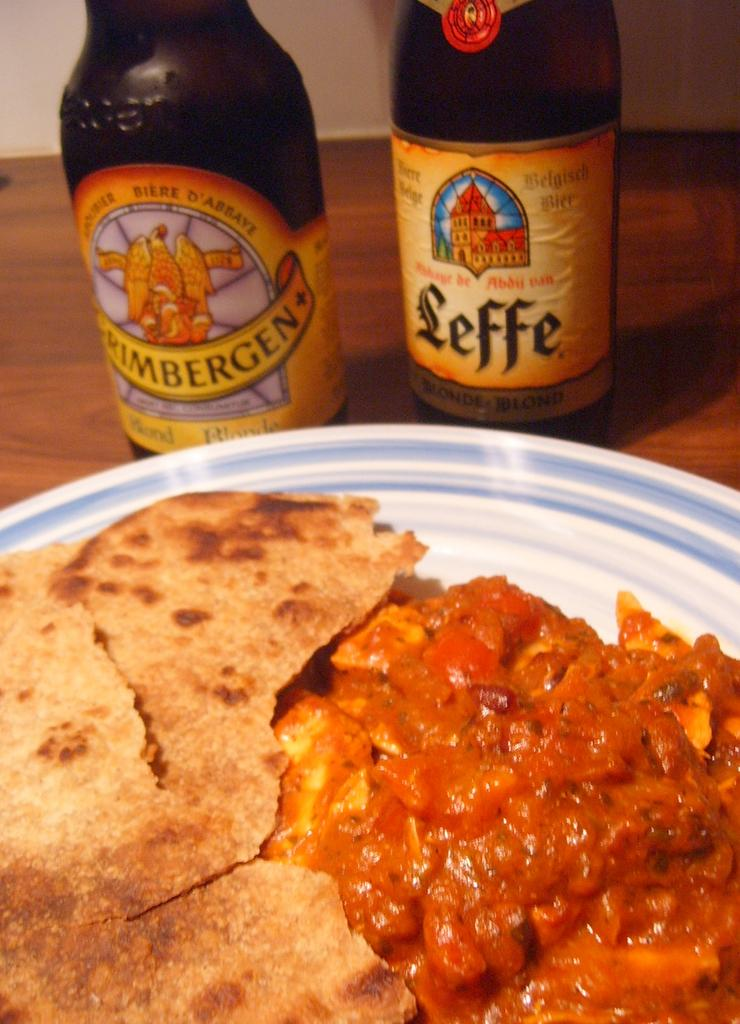Provide a one-sentence caption for the provided image. A brown bottle of beer with a yellow label that says Leffe. 